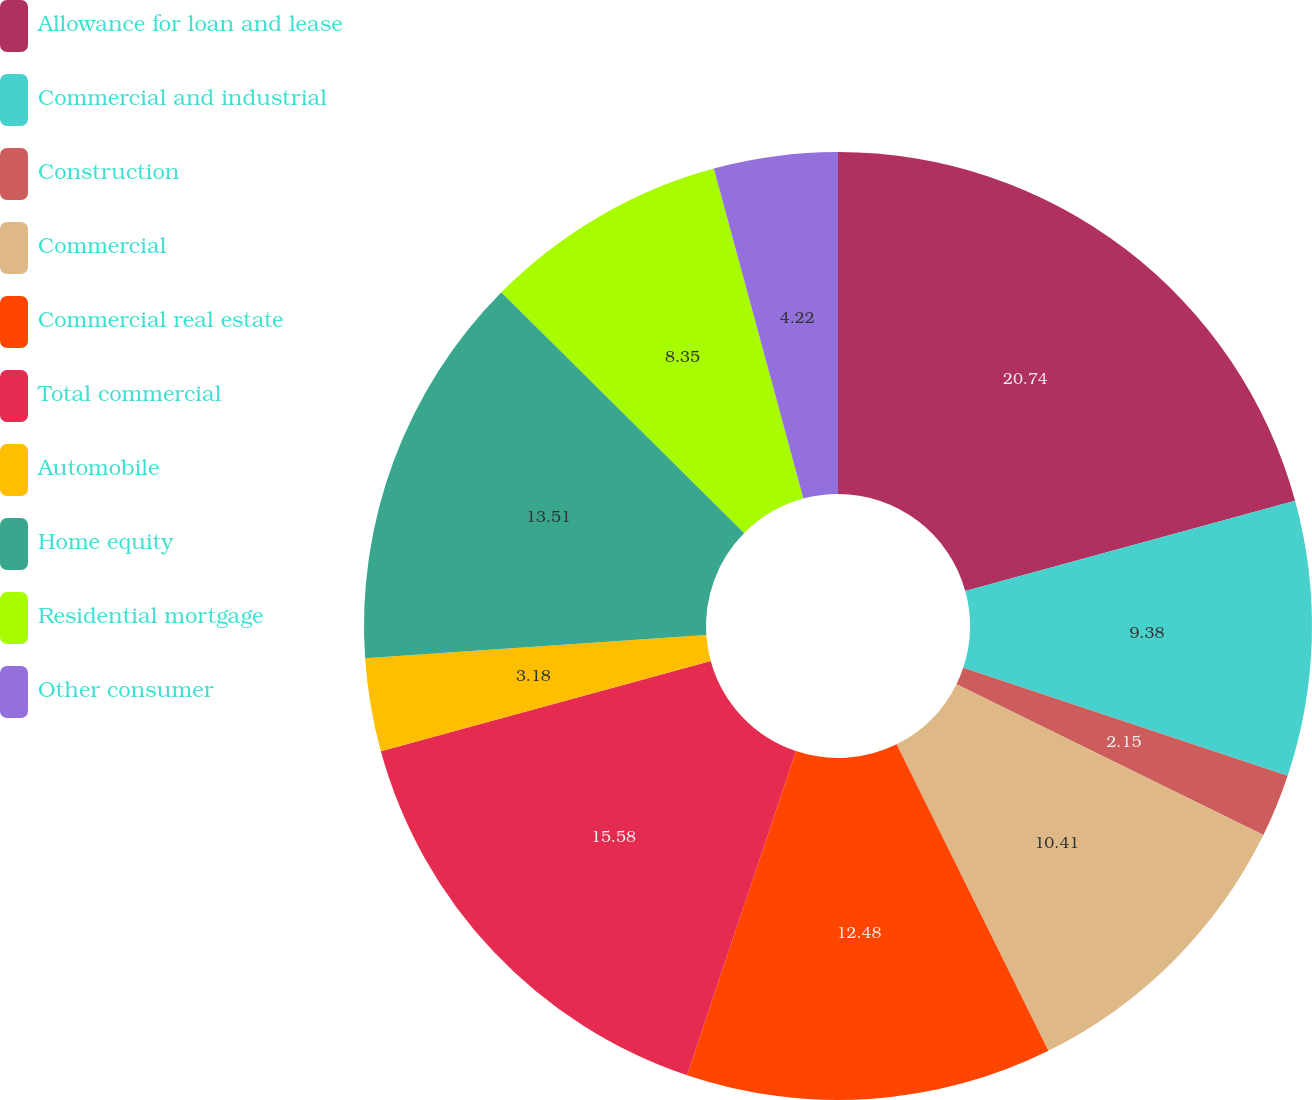Convert chart. <chart><loc_0><loc_0><loc_500><loc_500><pie_chart><fcel>Allowance for loan and lease<fcel>Commercial and industrial<fcel>Construction<fcel>Commercial<fcel>Commercial real estate<fcel>Total commercial<fcel>Automobile<fcel>Home equity<fcel>Residential mortgage<fcel>Other consumer<nl><fcel>20.74%<fcel>9.38%<fcel>2.15%<fcel>10.41%<fcel>12.48%<fcel>15.58%<fcel>3.18%<fcel>13.51%<fcel>8.35%<fcel>4.22%<nl></chart> 